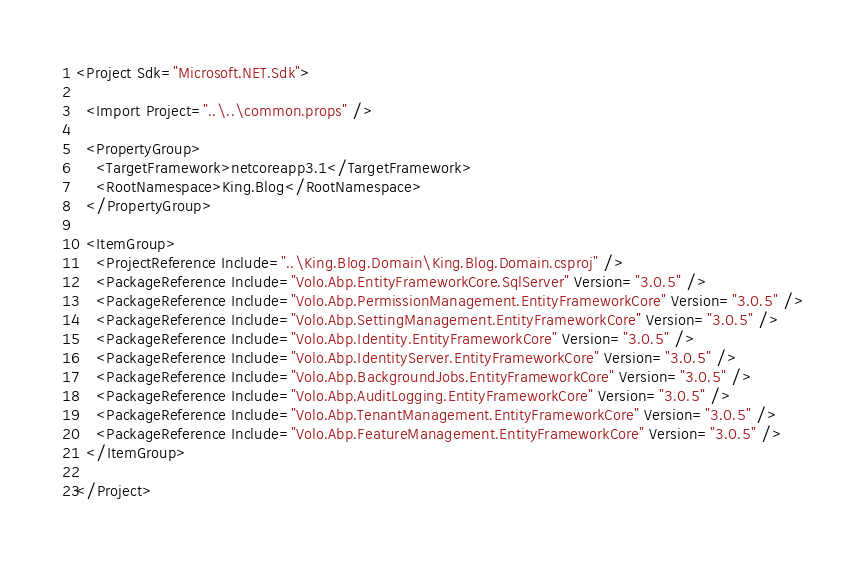<code> <loc_0><loc_0><loc_500><loc_500><_XML_><Project Sdk="Microsoft.NET.Sdk">

  <Import Project="..\..\common.props" />

  <PropertyGroup>
    <TargetFramework>netcoreapp3.1</TargetFramework>
    <RootNamespace>King.Blog</RootNamespace>
  </PropertyGroup>
  
  <ItemGroup>
    <ProjectReference Include="..\King.Blog.Domain\King.Blog.Domain.csproj" />
    <PackageReference Include="Volo.Abp.EntityFrameworkCore.SqlServer" Version="3.0.5" />
    <PackageReference Include="Volo.Abp.PermissionManagement.EntityFrameworkCore" Version="3.0.5" />
    <PackageReference Include="Volo.Abp.SettingManagement.EntityFrameworkCore" Version="3.0.5" />
    <PackageReference Include="Volo.Abp.Identity.EntityFrameworkCore" Version="3.0.5" />
    <PackageReference Include="Volo.Abp.IdentityServer.EntityFrameworkCore" Version="3.0.5" />
    <PackageReference Include="Volo.Abp.BackgroundJobs.EntityFrameworkCore" Version="3.0.5" />
    <PackageReference Include="Volo.Abp.AuditLogging.EntityFrameworkCore" Version="3.0.5" />
    <PackageReference Include="Volo.Abp.TenantManagement.EntityFrameworkCore" Version="3.0.5" />
    <PackageReference Include="Volo.Abp.FeatureManagement.EntityFrameworkCore" Version="3.0.5" />
  </ItemGroup>

</Project>
</code> 